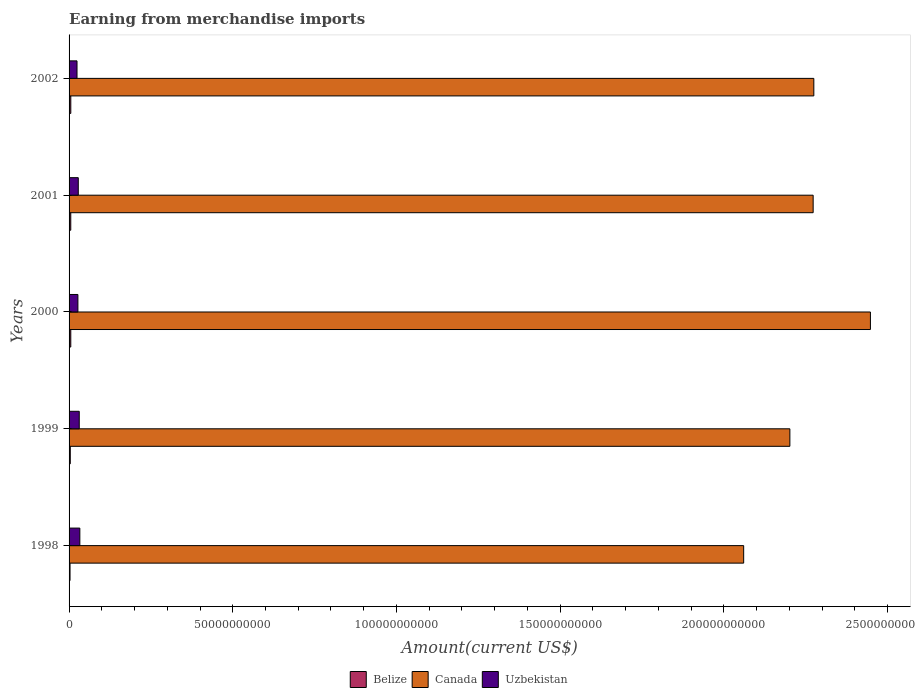Are the number of bars on each tick of the Y-axis equal?
Make the answer very short. Yes. What is the label of the 5th group of bars from the top?
Ensure brevity in your answer.  1998. What is the amount earned from merchandise imports in Belize in 2000?
Provide a succinct answer. 5.24e+08. Across all years, what is the maximum amount earned from merchandise imports in Canada?
Your answer should be compact. 2.45e+11. Across all years, what is the minimum amount earned from merchandise imports in Belize?
Make the answer very short. 2.95e+08. In which year was the amount earned from merchandise imports in Uzbekistan maximum?
Ensure brevity in your answer.  1998. What is the total amount earned from merchandise imports in Belize in the graph?
Offer a terse response. 2.23e+09. What is the difference between the amount earned from merchandise imports in Canada in 1999 and that in 2001?
Make the answer very short. -7.11e+09. What is the difference between the amount earned from merchandise imports in Belize in 1998 and the amount earned from merchandise imports in Canada in 1999?
Give a very brief answer. -2.20e+11. What is the average amount earned from merchandise imports in Belize per year?
Keep it short and to the point. 4.46e+08. In the year 2000, what is the difference between the amount earned from merchandise imports in Canada and amount earned from merchandise imports in Belize?
Make the answer very short. 2.44e+11. What is the ratio of the amount earned from merchandise imports in Canada in 1999 to that in 2001?
Provide a short and direct response. 0.97. Is the amount earned from merchandise imports in Canada in 1998 less than that in 1999?
Make the answer very short. Yes. Is the difference between the amount earned from merchandise imports in Canada in 1998 and 2000 greater than the difference between the amount earned from merchandise imports in Belize in 1998 and 2000?
Your answer should be compact. No. What is the difference between the highest and the second highest amount earned from merchandise imports in Uzbekistan?
Provide a short and direct response. 1.80e+08. What is the difference between the highest and the lowest amount earned from merchandise imports in Canada?
Provide a succinct answer. 3.87e+1. What does the 3rd bar from the top in 1999 represents?
Provide a short and direct response. Belize. What does the 1st bar from the bottom in 1998 represents?
Your answer should be very brief. Belize. Is it the case that in every year, the sum of the amount earned from merchandise imports in Canada and amount earned from merchandise imports in Belize is greater than the amount earned from merchandise imports in Uzbekistan?
Offer a terse response. Yes. How many bars are there?
Give a very brief answer. 15. How many years are there in the graph?
Your answer should be very brief. 5. Does the graph contain grids?
Provide a succinct answer. No. How many legend labels are there?
Your response must be concise. 3. What is the title of the graph?
Make the answer very short. Earning from merchandise imports. Does "Heavily indebted poor countries" appear as one of the legend labels in the graph?
Offer a very short reply. No. What is the label or title of the X-axis?
Provide a succinct answer. Amount(current US$). What is the label or title of the Y-axis?
Give a very brief answer. Years. What is the Amount(current US$) of Belize in 1998?
Keep it short and to the point. 2.95e+08. What is the Amount(current US$) of Canada in 1998?
Provide a succinct answer. 2.06e+11. What is the Amount(current US$) of Uzbekistan in 1998?
Provide a short and direct response. 3.29e+09. What is the Amount(current US$) in Belize in 1999?
Keep it short and to the point. 3.70e+08. What is the Amount(current US$) of Canada in 1999?
Ensure brevity in your answer.  2.20e+11. What is the Amount(current US$) in Uzbekistan in 1999?
Your answer should be very brief. 3.11e+09. What is the Amount(current US$) in Belize in 2000?
Offer a terse response. 5.24e+08. What is the Amount(current US$) of Canada in 2000?
Make the answer very short. 2.45e+11. What is the Amount(current US$) in Uzbekistan in 2000?
Your answer should be compact. 2.70e+09. What is the Amount(current US$) of Belize in 2001?
Offer a very short reply. 5.17e+08. What is the Amount(current US$) of Canada in 2001?
Offer a terse response. 2.27e+11. What is the Amount(current US$) of Uzbekistan in 2001?
Your answer should be very brief. 2.81e+09. What is the Amount(current US$) in Belize in 2002?
Give a very brief answer. 5.25e+08. What is the Amount(current US$) in Canada in 2002?
Your answer should be very brief. 2.27e+11. What is the Amount(current US$) in Uzbekistan in 2002?
Provide a short and direct response. 2.42e+09. Across all years, what is the maximum Amount(current US$) in Belize?
Your answer should be very brief. 5.25e+08. Across all years, what is the maximum Amount(current US$) in Canada?
Provide a succinct answer. 2.45e+11. Across all years, what is the maximum Amount(current US$) of Uzbekistan?
Ensure brevity in your answer.  3.29e+09. Across all years, what is the minimum Amount(current US$) in Belize?
Give a very brief answer. 2.95e+08. Across all years, what is the minimum Amount(current US$) in Canada?
Keep it short and to the point. 2.06e+11. Across all years, what is the minimum Amount(current US$) in Uzbekistan?
Keep it short and to the point. 2.42e+09. What is the total Amount(current US$) of Belize in the graph?
Offer a terse response. 2.23e+09. What is the total Amount(current US$) of Canada in the graph?
Provide a short and direct response. 1.13e+12. What is the total Amount(current US$) of Uzbekistan in the graph?
Your answer should be compact. 1.43e+1. What is the difference between the Amount(current US$) of Belize in 1998 and that in 1999?
Offer a very short reply. -7.50e+07. What is the difference between the Amount(current US$) of Canada in 1998 and that in 1999?
Your answer should be compact. -1.41e+1. What is the difference between the Amount(current US$) of Uzbekistan in 1998 and that in 1999?
Your answer should be compact. 1.80e+08. What is the difference between the Amount(current US$) of Belize in 1998 and that in 2000?
Give a very brief answer. -2.29e+08. What is the difference between the Amount(current US$) in Canada in 1998 and that in 2000?
Make the answer very short. -3.87e+1. What is the difference between the Amount(current US$) of Uzbekistan in 1998 and that in 2000?
Provide a short and direct response. 5.93e+08. What is the difference between the Amount(current US$) in Belize in 1998 and that in 2001?
Your answer should be very brief. -2.22e+08. What is the difference between the Amount(current US$) in Canada in 1998 and that in 2001?
Ensure brevity in your answer.  -2.12e+1. What is the difference between the Amount(current US$) in Uzbekistan in 1998 and that in 2001?
Provide a short and direct response. 4.76e+08. What is the difference between the Amount(current US$) in Belize in 1998 and that in 2002?
Provide a short and direct response. -2.30e+08. What is the difference between the Amount(current US$) of Canada in 1998 and that in 2002?
Your response must be concise. -2.14e+1. What is the difference between the Amount(current US$) of Uzbekistan in 1998 and that in 2002?
Your response must be concise. 8.65e+08. What is the difference between the Amount(current US$) in Belize in 1999 and that in 2000?
Provide a succinct answer. -1.54e+08. What is the difference between the Amount(current US$) of Canada in 1999 and that in 2000?
Your answer should be compact. -2.46e+1. What is the difference between the Amount(current US$) of Uzbekistan in 1999 and that in 2000?
Offer a terse response. 4.13e+08. What is the difference between the Amount(current US$) in Belize in 1999 and that in 2001?
Offer a terse response. -1.47e+08. What is the difference between the Amount(current US$) of Canada in 1999 and that in 2001?
Give a very brief answer. -7.11e+09. What is the difference between the Amount(current US$) in Uzbekistan in 1999 and that in 2001?
Give a very brief answer. 2.96e+08. What is the difference between the Amount(current US$) of Belize in 1999 and that in 2002?
Make the answer very short. -1.55e+08. What is the difference between the Amount(current US$) in Canada in 1999 and that in 2002?
Give a very brief answer. -7.32e+09. What is the difference between the Amount(current US$) of Uzbekistan in 1999 and that in 2002?
Give a very brief answer. 6.85e+08. What is the difference between the Amount(current US$) in Belize in 2000 and that in 2001?
Give a very brief answer. 7.00e+06. What is the difference between the Amount(current US$) of Canada in 2000 and that in 2001?
Provide a succinct answer. 1.75e+1. What is the difference between the Amount(current US$) of Uzbekistan in 2000 and that in 2001?
Make the answer very short. -1.17e+08. What is the difference between the Amount(current US$) in Canada in 2000 and that in 2002?
Provide a succinct answer. 1.73e+1. What is the difference between the Amount(current US$) of Uzbekistan in 2000 and that in 2002?
Provide a succinct answer. 2.72e+08. What is the difference between the Amount(current US$) of Belize in 2001 and that in 2002?
Your answer should be very brief. -8.00e+06. What is the difference between the Amount(current US$) of Canada in 2001 and that in 2002?
Give a very brief answer. -2.08e+08. What is the difference between the Amount(current US$) of Uzbekistan in 2001 and that in 2002?
Keep it short and to the point. 3.89e+08. What is the difference between the Amount(current US$) of Belize in 1998 and the Amount(current US$) of Canada in 1999?
Ensure brevity in your answer.  -2.20e+11. What is the difference between the Amount(current US$) of Belize in 1998 and the Amount(current US$) of Uzbekistan in 1999?
Your response must be concise. -2.82e+09. What is the difference between the Amount(current US$) in Canada in 1998 and the Amount(current US$) in Uzbekistan in 1999?
Offer a terse response. 2.03e+11. What is the difference between the Amount(current US$) of Belize in 1998 and the Amount(current US$) of Canada in 2000?
Offer a terse response. -2.44e+11. What is the difference between the Amount(current US$) of Belize in 1998 and the Amount(current US$) of Uzbekistan in 2000?
Offer a terse response. -2.40e+09. What is the difference between the Amount(current US$) in Canada in 1998 and the Amount(current US$) in Uzbekistan in 2000?
Your answer should be compact. 2.03e+11. What is the difference between the Amount(current US$) in Belize in 1998 and the Amount(current US$) in Canada in 2001?
Offer a terse response. -2.27e+11. What is the difference between the Amount(current US$) in Belize in 1998 and the Amount(current US$) in Uzbekistan in 2001?
Your answer should be very brief. -2.52e+09. What is the difference between the Amount(current US$) in Canada in 1998 and the Amount(current US$) in Uzbekistan in 2001?
Offer a terse response. 2.03e+11. What is the difference between the Amount(current US$) in Belize in 1998 and the Amount(current US$) in Canada in 2002?
Your answer should be compact. -2.27e+11. What is the difference between the Amount(current US$) of Belize in 1998 and the Amount(current US$) of Uzbekistan in 2002?
Give a very brief answer. -2.13e+09. What is the difference between the Amount(current US$) in Canada in 1998 and the Amount(current US$) in Uzbekistan in 2002?
Your answer should be very brief. 2.04e+11. What is the difference between the Amount(current US$) in Belize in 1999 and the Amount(current US$) in Canada in 2000?
Your response must be concise. -2.44e+11. What is the difference between the Amount(current US$) in Belize in 1999 and the Amount(current US$) in Uzbekistan in 2000?
Make the answer very short. -2.33e+09. What is the difference between the Amount(current US$) in Canada in 1999 and the Amount(current US$) in Uzbekistan in 2000?
Ensure brevity in your answer.  2.17e+11. What is the difference between the Amount(current US$) of Belize in 1999 and the Amount(current US$) of Canada in 2001?
Provide a short and direct response. -2.27e+11. What is the difference between the Amount(current US$) of Belize in 1999 and the Amount(current US$) of Uzbekistan in 2001?
Provide a short and direct response. -2.44e+09. What is the difference between the Amount(current US$) in Canada in 1999 and the Amount(current US$) in Uzbekistan in 2001?
Keep it short and to the point. 2.17e+11. What is the difference between the Amount(current US$) in Belize in 1999 and the Amount(current US$) in Canada in 2002?
Your answer should be very brief. -2.27e+11. What is the difference between the Amount(current US$) of Belize in 1999 and the Amount(current US$) of Uzbekistan in 2002?
Provide a succinct answer. -2.06e+09. What is the difference between the Amount(current US$) of Canada in 1999 and the Amount(current US$) of Uzbekistan in 2002?
Make the answer very short. 2.18e+11. What is the difference between the Amount(current US$) in Belize in 2000 and the Amount(current US$) in Canada in 2001?
Offer a very short reply. -2.27e+11. What is the difference between the Amount(current US$) of Belize in 2000 and the Amount(current US$) of Uzbekistan in 2001?
Offer a very short reply. -2.29e+09. What is the difference between the Amount(current US$) of Canada in 2000 and the Amount(current US$) of Uzbekistan in 2001?
Offer a terse response. 2.42e+11. What is the difference between the Amount(current US$) of Belize in 2000 and the Amount(current US$) of Canada in 2002?
Give a very brief answer. -2.27e+11. What is the difference between the Amount(current US$) of Belize in 2000 and the Amount(current US$) of Uzbekistan in 2002?
Provide a succinct answer. -1.90e+09. What is the difference between the Amount(current US$) in Canada in 2000 and the Amount(current US$) in Uzbekistan in 2002?
Offer a terse response. 2.42e+11. What is the difference between the Amount(current US$) in Belize in 2001 and the Amount(current US$) in Canada in 2002?
Give a very brief answer. -2.27e+11. What is the difference between the Amount(current US$) in Belize in 2001 and the Amount(current US$) in Uzbekistan in 2002?
Your answer should be compact. -1.91e+09. What is the difference between the Amount(current US$) of Canada in 2001 and the Amount(current US$) of Uzbekistan in 2002?
Provide a succinct answer. 2.25e+11. What is the average Amount(current US$) in Belize per year?
Offer a very short reply. 4.46e+08. What is the average Amount(current US$) of Canada per year?
Your answer should be very brief. 2.25e+11. What is the average Amount(current US$) of Uzbekistan per year?
Offer a very short reply. 2.87e+09. In the year 1998, what is the difference between the Amount(current US$) of Belize and Amount(current US$) of Canada?
Your answer should be compact. -2.06e+11. In the year 1998, what is the difference between the Amount(current US$) of Belize and Amount(current US$) of Uzbekistan?
Your response must be concise. -3.00e+09. In the year 1998, what is the difference between the Amount(current US$) in Canada and Amount(current US$) in Uzbekistan?
Offer a terse response. 2.03e+11. In the year 1999, what is the difference between the Amount(current US$) of Belize and Amount(current US$) of Canada?
Give a very brief answer. -2.20e+11. In the year 1999, what is the difference between the Amount(current US$) of Belize and Amount(current US$) of Uzbekistan?
Your answer should be very brief. -2.74e+09. In the year 1999, what is the difference between the Amount(current US$) in Canada and Amount(current US$) in Uzbekistan?
Make the answer very short. 2.17e+11. In the year 2000, what is the difference between the Amount(current US$) of Belize and Amount(current US$) of Canada?
Your answer should be very brief. -2.44e+11. In the year 2000, what is the difference between the Amount(current US$) in Belize and Amount(current US$) in Uzbekistan?
Keep it short and to the point. -2.17e+09. In the year 2000, what is the difference between the Amount(current US$) in Canada and Amount(current US$) in Uzbekistan?
Your answer should be compact. 2.42e+11. In the year 2001, what is the difference between the Amount(current US$) of Belize and Amount(current US$) of Canada?
Your answer should be very brief. -2.27e+11. In the year 2001, what is the difference between the Amount(current US$) in Belize and Amount(current US$) in Uzbekistan?
Keep it short and to the point. -2.30e+09. In the year 2001, what is the difference between the Amount(current US$) in Canada and Amount(current US$) in Uzbekistan?
Keep it short and to the point. 2.24e+11. In the year 2002, what is the difference between the Amount(current US$) of Belize and Amount(current US$) of Canada?
Provide a succinct answer. -2.27e+11. In the year 2002, what is the difference between the Amount(current US$) in Belize and Amount(current US$) in Uzbekistan?
Ensure brevity in your answer.  -1.90e+09. In the year 2002, what is the difference between the Amount(current US$) of Canada and Amount(current US$) of Uzbekistan?
Your answer should be compact. 2.25e+11. What is the ratio of the Amount(current US$) in Belize in 1998 to that in 1999?
Provide a short and direct response. 0.8. What is the ratio of the Amount(current US$) of Canada in 1998 to that in 1999?
Ensure brevity in your answer.  0.94. What is the ratio of the Amount(current US$) in Uzbekistan in 1998 to that in 1999?
Offer a terse response. 1.06. What is the ratio of the Amount(current US$) of Belize in 1998 to that in 2000?
Your response must be concise. 0.56. What is the ratio of the Amount(current US$) of Canada in 1998 to that in 2000?
Your response must be concise. 0.84. What is the ratio of the Amount(current US$) in Uzbekistan in 1998 to that in 2000?
Make the answer very short. 1.22. What is the ratio of the Amount(current US$) of Belize in 1998 to that in 2001?
Keep it short and to the point. 0.57. What is the ratio of the Amount(current US$) in Canada in 1998 to that in 2001?
Ensure brevity in your answer.  0.91. What is the ratio of the Amount(current US$) of Uzbekistan in 1998 to that in 2001?
Your answer should be very brief. 1.17. What is the ratio of the Amount(current US$) in Belize in 1998 to that in 2002?
Offer a very short reply. 0.56. What is the ratio of the Amount(current US$) of Canada in 1998 to that in 2002?
Your answer should be very brief. 0.91. What is the ratio of the Amount(current US$) in Uzbekistan in 1998 to that in 2002?
Ensure brevity in your answer.  1.36. What is the ratio of the Amount(current US$) of Belize in 1999 to that in 2000?
Provide a succinct answer. 0.71. What is the ratio of the Amount(current US$) of Canada in 1999 to that in 2000?
Ensure brevity in your answer.  0.9. What is the ratio of the Amount(current US$) in Uzbekistan in 1999 to that in 2000?
Provide a short and direct response. 1.15. What is the ratio of the Amount(current US$) of Belize in 1999 to that in 2001?
Ensure brevity in your answer.  0.72. What is the ratio of the Amount(current US$) in Canada in 1999 to that in 2001?
Your response must be concise. 0.97. What is the ratio of the Amount(current US$) in Uzbekistan in 1999 to that in 2001?
Your answer should be very brief. 1.11. What is the ratio of the Amount(current US$) in Belize in 1999 to that in 2002?
Ensure brevity in your answer.  0.7. What is the ratio of the Amount(current US$) in Canada in 1999 to that in 2002?
Your response must be concise. 0.97. What is the ratio of the Amount(current US$) in Uzbekistan in 1999 to that in 2002?
Your response must be concise. 1.28. What is the ratio of the Amount(current US$) of Belize in 2000 to that in 2001?
Provide a succinct answer. 1.01. What is the ratio of the Amount(current US$) of Canada in 2000 to that in 2001?
Keep it short and to the point. 1.08. What is the ratio of the Amount(current US$) in Uzbekistan in 2000 to that in 2001?
Your answer should be very brief. 0.96. What is the ratio of the Amount(current US$) of Belize in 2000 to that in 2002?
Provide a short and direct response. 1. What is the ratio of the Amount(current US$) of Canada in 2000 to that in 2002?
Make the answer very short. 1.08. What is the ratio of the Amount(current US$) in Uzbekistan in 2000 to that in 2002?
Your response must be concise. 1.11. What is the ratio of the Amount(current US$) in Canada in 2001 to that in 2002?
Provide a succinct answer. 1. What is the ratio of the Amount(current US$) of Uzbekistan in 2001 to that in 2002?
Your answer should be compact. 1.16. What is the difference between the highest and the second highest Amount(current US$) of Canada?
Offer a very short reply. 1.73e+1. What is the difference between the highest and the second highest Amount(current US$) in Uzbekistan?
Provide a short and direct response. 1.80e+08. What is the difference between the highest and the lowest Amount(current US$) in Belize?
Provide a succinct answer. 2.30e+08. What is the difference between the highest and the lowest Amount(current US$) in Canada?
Ensure brevity in your answer.  3.87e+1. What is the difference between the highest and the lowest Amount(current US$) in Uzbekistan?
Provide a succinct answer. 8.65e+08. 